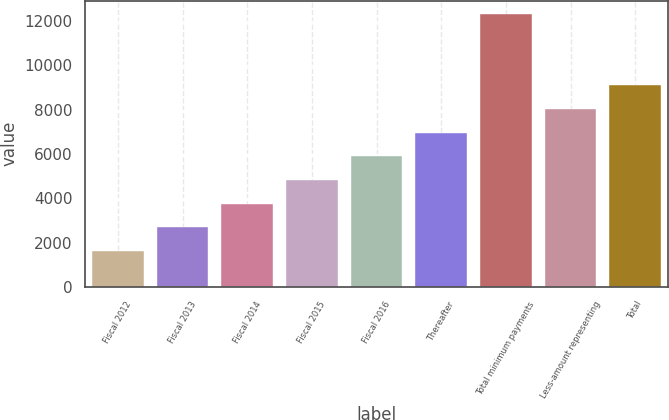<chart> <loc_0><loc_0><loc_500><loc_500><bar_chart><fcel>Fiscal 2012<fcel>Fiscal 2013<fcel>Fiscal 2014<fcel>Fiscal 2015<fcel>Fiscal 2016<fcel>Thereafter<fcel>Total minimum payments<fcel>Less-amount representing<fcel>Total<nl><fcel>1616<fcel>2685.1<fcel>3754.2<fcel>4823.3<fcel>5892.4<fcel>6961.5<fcel>12307<fcel>8030.6<fcel>9099.7<nl></chart> 